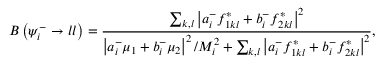Convert formula to latex. <formula><loc_0><loc_0><loc_500><loc_500>B \left ( \psi _ { i } ^ { - } \to l l \right ) = { \frac { \sum _ { k , l } \left | a _ { i } ^ { - } f _ { 1 k l } ^ { \ast } + b _ { i } ^ { - } f _ { 2 k l } ^ { \ast } \right | ^ { 2 } } { \left | a _ { i } ^ { - } \mu _ { 1 } + b _ { i } ^ { - } \mu _ { 2 } \right | ^ { 2 } / M _ { i } ^ { 2 } + \sum _ { k , l } \left | a _ { i } ^ { - } f _ { 1 k l } ^ { * } + b _ { i } ^ { - } f _ { 2 k l } ^ { * } \right | ^ { 2 } } } ,</formula> 